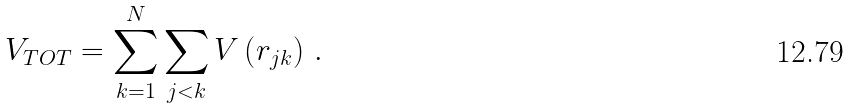Convert formula to latex. <formula><loc_0><loc_0><loc_500><loc_500>V _ { T O T } = \sum _ { k = 1 } ^ { N } \sum _ { j < k } V \left ( r _ { j k } \right ) \, .</formula> 